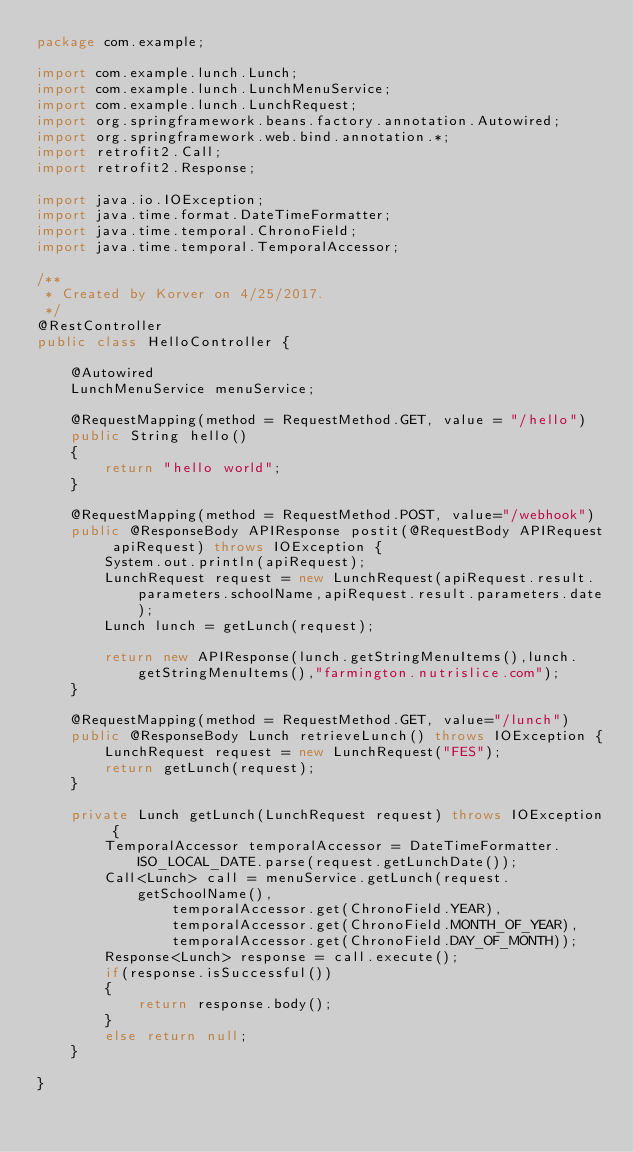<code> <loc_0><loc_0><loc_500><loc_500><_Java_>package com.example;

import com.example.lunch.Lunch;
import com.example.lunch.LunchMenuService;
import com.example.lunch.LunchRequest;
import org.springframework.beans.factory.annotation.Autowired;
import org.springframework.web.bind.annotation.*;
import retrofit2.Call;
import retrofit2.Response;

import java.io.IOException;
import java.time.format.DateTimeFormatter;
import java.time.temporal.ChronoField;
import java.time.temporal.TemporalAccessor;

/**
 * Created by Korver on 4/25/2017.
 */
@RestController
public class HelloController {

    @Autowired
    LunchMenuService menuService;

    @RequestMapping(method = RequestMethod.GET, value = "/hello")
    public String hello()
    {
        return "hello world";
    }

    @RequestMapping(method = RequestMethod.POST, value="/webhook")
    public @ResponseBody APIResponse postit(@RequestBody APIRequest apiRequest) throws IOException {
        System.out.println(apiRequest);
        LunchRequest request = new LunchRequest(apiRequest.result.parameters.schoolName,apiRequest.result.parameters.date);
        Lunch lunch = getLunch(request);

        return new APIResponse(lunch.getStringMenuItems(),lunch.getStringMenuItems(),"farmington.nutrislice.com");
    }

    @RequestMapping(method = RequestMethod.GET, value="/lunch")
    public @ResponseBody Lunch retrieveLunch() throws IOException {
        LunchRequest request = new LunchRequest("FES");
        return getLunch(request);
    }

    private Lunch getLunch(LunchRequest request) throws IOException {
        TemporalAccessor temporalAccessor = DateTimeFormatter.ISO_LOCAL_DATE.parse(request.getLunchDate());
        Call<Lunch> call = menuService.getLunch(request.getSchoolName(),
                temporalAccessor.get(ChronoField.YEAR),
                temporalAccessor.get(ChronoField.MONTH_OF_YEAR),
                temporalAccessor.get(ChronoField.DAY_OF_MONTH));
        Response<Lunch> response = call.execute();
        if(response.isSuccessful())
        {
            return response.body();
        }
        else return null;
    }

}
</code> 